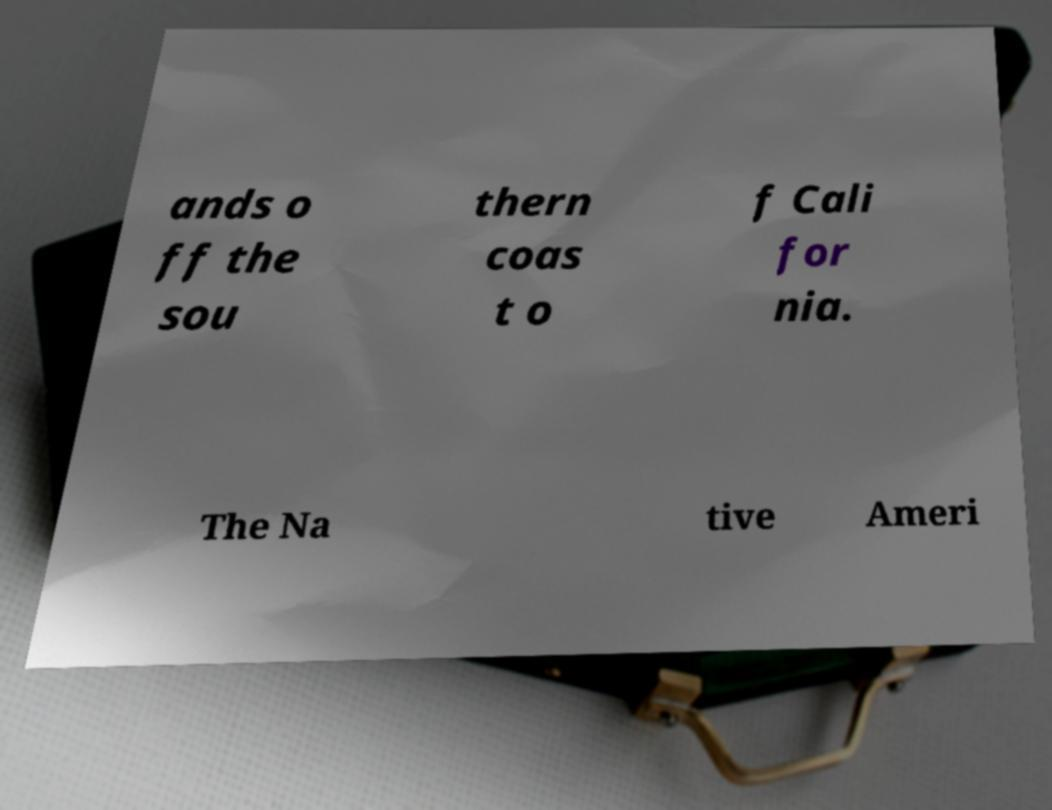I need the written content from this picture converted into text. Can you do that? ands o ff the sou thern coas t o f Cali for nia. The Na tive Ameri 